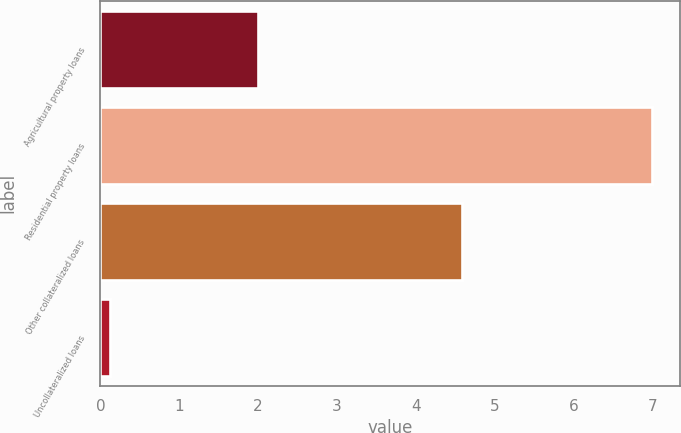<chart> <loc_0><loc_0><loc_500><loc_500><bar_chart><fcel>Agricultural property loans<fcel>Residential property loans<fcel>Other collateralized loans<fcel>Uncollateralized loans<nl><fcel>2<fcel>7<fcel>4.59<fcel>0.12<nl></chart> 